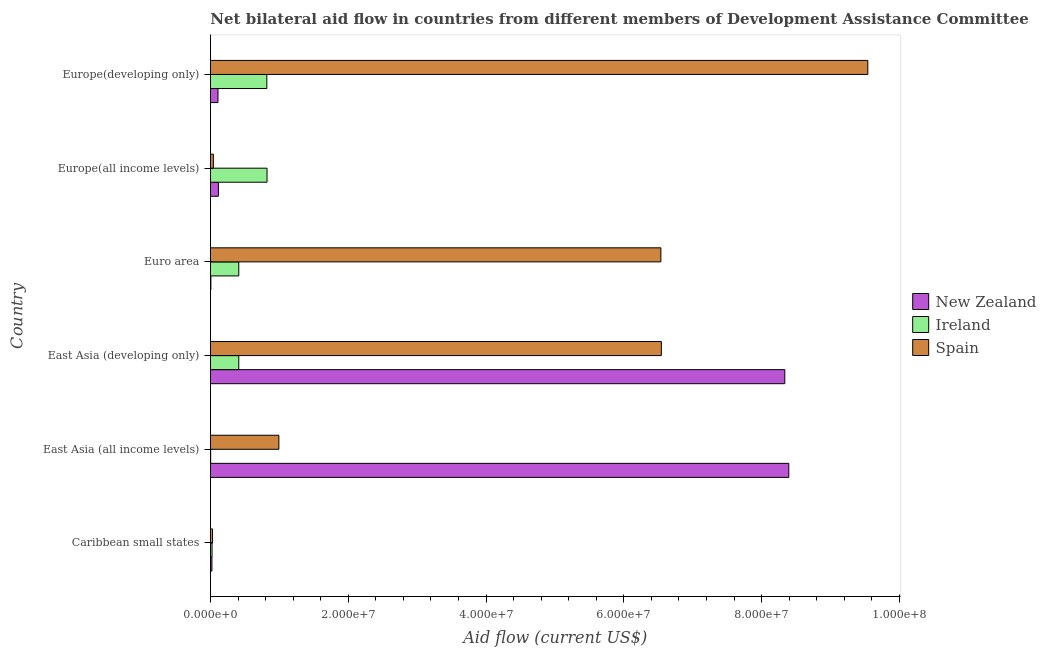How many different coloured bars are there?
Keep it short and to the point. 3. Are the number of bars on each tick of the Y-axis equal?
Your response must be concise. Yes. How many bars are there on the 6th tick from the top?
Ensure brevity in your answer.  3. How many bars are there on the 6th tick from the bottom?
Provide a succinct answer. 3. What is the label of the 1st group of bars from the top?
Provide a short and direct response. Europe(developing only). What is the amount of aid provided by new zealand in Euro area?
Keep it short and to the point. 6.00e+04. Across all countries, what is the maximum amount of aid provided by spain?
Offer a very short reply. 9.54e+07. Across all countries, what is the minimum amount of aid provided by new zealand?
Your answer should be very brief. 6.00e+04. In which country was the amount of aid provided by ireland maximum?
Provide a short and direct response. Europe(all income levels). In which country was the amount of aid provided by ireland minimum?
Keep it short and to the point. East Asia (all income levels). What is the total amount of aid provided by spain in the graph?
Your answer should be compact. 2.37e+08. What is the difference between the amount of aid provided by new zealand in East Asia (developing only) and that in Euro area?
Offer a very short reply. 8.33e+07. What is the difference between the amount of aid provided by new zealand in Caribbean small states and the amount of aid provided by ireland in East Asia (developing only)?
Your response must be concise. -3.90e+06. What is the average amount of aid provided by new zealand per country?
Offer a terse response. 2.83e+07. What is the difference between the amount of aid provided by spain and amount of aid provided by ireland in Europe(developing only)?
Offer a very short reply. 8.72e+07. In how many countries, is the amount of aid provided by new zealand greater than 20000000 US$?
Provide a short and direct response. 2. What is the ratio of the amount of aid provided by new zealand in Europe(all income levels) to that in Europe(developing only)?
Provide a short and direct response. 1.05. Is the difference between the amount of aid provided by spain in Europe(all income levels) and Europe(developing only) greater than the difference between the amount of aid provided by new zealand in Europe(all income levels) and Europe(developing only)?
Your response must be concise. No. What is the difference between the highest and the second highest amount of aid provided by ireland?
Provide a succinct answer. 3.00e+04. What is the difference between the highest and the lowest amount of aid provided by new zealand?
Ensure brevity in your answer.  8.39e+07. Is the sum of the amount of aid provided by new zealand in East Asia (all income levels) and Euro area greater than the maximum amount of aid provided by spain across all countries?
Offer a terse response. No. What does the 3rd bar from the top in East Asia (all income levels) represents?
Your response must be concise. New Zealand. What is the difference between two consecutive major ticks on the X-axis?
Your answer should be very brief. 2.00e+07. Are the values on the major ticks of X-axis written in scientific E-notation?
Offer a very short reply. Yes. Where does the legend appear in the graph?
Keep it short and to the point. Center right. How many legend labels are there?
Offer a terse response. 3. What is the title of the graph?
Your answer should be compact. Net bilateral aid flow in countries from different members of Development Assistance Committee. Does "ICT services" appear as one of the legend labels in the graph?
Your answer should be very brief. No. What is the label or title of the X-axis?
Offer a terse response. Aid flow (current US$). What is the Aid flow (current US$) in New Zealand in Caribbean small states?
Offer a terse response. 2.10e+05. What is the Aid flow (current US$) in Spain in Caribbean small states?
Offer a terse response. 3.00e+05. What is the Aid flow (current US$) of New Zealand in East Asia (all income levels)?
Make the answer very short. 8.40e+07. What is the Aid flow (current US$) in Ireland in East Asia (all income levels)?
Your answer should be compact. 3.00e+04. What is the Aid flow (current US$) in Spain in East Asia (all income levels)?
Keep it short and to the point. 9.93e+06. What is the Aid flow (current US$) in New Zealand in East Asia (developing only)?
Give a very brief answer. 8.34e+07. What is the Aid flow (current US$) of Ireland in East Asia (developing only)?
Provide a short and direct response. 4.11e+06. What is the Aid flow (current US$) of Spain in East Asia (developing only)?
Your answer should be very brief. 6.54e+07. What is the Aid flow (current US$) of Ireland in Euro area?
Make the answer very short. 4.11e+06. What is the Aid flow (current US$) of Spain in Euro area?
Make the answer very short. 6.54e+07. What is the Aid flow (current US$) of New Zealand in Europe(all income levels)?
Offer a very short reply. 1.15e+06. What is the Aid flow (current US$) in Ireland in Europe(all income levels)?
Ensure brevity in your answer.  8.21e+06. What is the Aid flow (current US$) in New Zealand in Europe(developing only)?
Give a very brief answer. 1.09e+06. What is the Aid flow (current US$) in Ireland in Europe(developing only)?
Make the answer very short. 8.18e+06. What is the Aid flow (current US$) in Spain in Europe(developing only)?
Ensure brevity in your answer.  9.54e+07. Across all countries, what is the maximum Aid flow (current US$) in New Zealand?
Keep it short and to the point. 8.40e+07. Across all countries, what is the maximum Aid flow (current US$) in Ireland?
Ensure brevity in your answer.  8.21e+06. Across all countries, what is the maximum Aid flow (current US$) of Spain?
Keep it short and to the point. 9.54e+07. What is the total Aid flow (current US$) in New Zealand in the graph?
Your response must be concise. 1.70e+08. What is the total Aid flow (current US$) in Ireland in the graph?
Make the answer very short. 2.49e+07. What is the total Aid flow (current US$) of Spain in the graph?
Make the answer very short. 2.37e+08. What is the difference between the Aid flow (current US$) in New Zealand in Caribbean small states and that in East Asia (all income levels)?
Your response must be concise. -8.37e+07. What is the difference between the Aid flow (current US$) in Spain in Caribbean small states and that in East Asia (all income levels)?
Your response must be concise. -9.63e+06. What is the difference between the Aid flow (current US$) of New Zealand in Caribbean small states and that in East Asia (developing only)?
Your answer should be very brief. -8.32e+07. What is the difference between the Aid flow (current US$) in Ireland in Caribbean small states and that in East Asia (developing only)?
Offer a very short reply. -3.88e+06. What is the difference between the Aid flow (current US$) of Spain in Caribbean small states and that in East Asia (developing only)?
Give a very brief answer. -6.52e+07. What is the difference between the Aid flow (current US$) of New Zealand in Caribbean small states and that in Euro area?
Ensure brevity in your answer.  1.50e+05. What is the difference between the Aid flow (current US$) of Ireland in Caribbean small states and that in Euro area?
Provide a succinct answer. -3.88e+06. What is the difference between the Aid flow (current US$) of Spain in Caribbean small states and that in Euro area?
Provide a succinct answer. -6.51e+07. What is the difference between the Aid flow (current US$) of New Zealand in Caribbean small states and that in Europe(all income levels)?
Offer a very short reply. -9.40e+05. What is the difference between the Aid flow (current US$) in Ireland in Caribbean small states and that in Europe(all income levels)?
Offer a terse response. -7.98e+06. What is the difference between the Aid flow (current US$) of Spain in Caribbean small states and that in Europe(all income levels)?
Make the answer very short. -1.20e+05. What is the difference between the Aid flow (current US$) of New Zealand in Caribbean small states and that in Europe(developing only)?
Provide a short and direct response. -8.80e+05. What is the difference between the Aid flow (current US$) of Ireland in Caribbean small states and that in Europe(developing only)?
Keep it short and to the point. -7.95e+06. What is the difference between the Aid flow (current US$) of Spain in Caribbean small states and that in Europe(developing only)?
Offer a terse response. -9.51e+07. What is the difference between the Aid flow (current US$) of New Zealand in East Asia (all income levels) and that in East Asia (developing only)?
Your answer should be compact. 5.80e+05. What is the difference between the Aid flow (current US$) of Ireland in East Asia (all income levels) and that in East Asia (developing only)?
Your answer should be compact. -4.08e+06. What is the difference between the Aid flow (current US$) of Spain in East Asia (all income levels) and that in East Asia (developing only)?
Keep it short and to the point. -5.55e+07. What is the difference between the Aid flow (current US$) in New Zealand in East Asia (all income levels) and that in Euro area?
Offer a terse response. 8.39e+07. What is the difference between the Aid flow (current US$) in Ireland in East Asia (all income levels) and that in Euro area?
Ensure brevity in your answer.  -4.08e+06. What is the difference between the Aid flow (current US$) of Spain in East Asia (all income levels) and that in Euro area?
Keep it short and to the point. -5.54e+07. What is the difference between the Aid flow (current US$) in New Zealand in East Asia (all income levels) and that in Europe(all income levels)?
Offer a terse response. 8.28e+07. What is the difference between the Aid flow (current US$) of Ireland in East Asia (all income levels) and that in Europe(all income levels)?
Make the answer very short. -8.18e+06. What is the difference between the Aid flow (current US$) in Spain in East Asia (all income levels) and that in Europe(all income levels)?
Ensure brevity in your answer.  9.51e+06. What is the difference between the Aid flow (current US$) of New Zealand in East Asia (all income levels) and that in Europe(developing only)?
Your answer should be very brief. 8.29e+07. What is the difference between the Aid flow (current US$) of Ireland in East Asia (all income levels) and that in Europe(developing only)?
Offer a terse response. -8.15e+06. What is the difference between the Aid flow (current US$) of Spain in East Asia (all income levels) and that in Europe(developing only)?
Provide a short and direct response. -8.55e+07. What is the difference between the Aid flow (current US$) of New Zealand in East Asia (developing only) and that in Euro area?
Ensure brevity in your answer.  8.33e+07. What is the difference between the Aid flow (current US$) of New Zealand in East Asia (developing only) and that in Europe(all income levels)?
Offer a terse response. 8.22e+07. What is the difference between the Aid flow (current US$) of Ireland in East Asia (developing only) and that in Europe(all income levels)?
Give a very brief answer. -4.10e+06. What is the difference between the Aid flow (current US$) of Spain in East Asia (developing only) and that in Europe(all income levels)?
Ensure brevity in your answer.  6.50e+07. What is the difference between the Aid flow (current US$) of New Zealand in East Asia (developing only) and that in Europe(developing only)?
Offer a very short reply. 8.23e+07. What is the difference between the Aid flow (current US$) in Ireland in East Asia (developing only) and that in Europe(developing only)?
Offer a very short reply. -4.07e+06. What is the difference between the Aid flow (current US$) of Spain in East Asia (developing only) and that in Europe(developing only)?
Keep it short and to the point. -3.00e+07. What is the difference between the Aid flow (current US$) of New Zealand in Euro area and that in Europe(all income levels)?
Give a very brief answer. -1.09e+06. What is the difference between the Aid flow (current US$) of Ireland in Euro area and that in Europe(all income levels)?
Provide a short and direct response. -4.10e+06. What is the difference between the Aid flow (current US$) in Spain in Euro area and that in Europe(all income levels)?
Your answer should be very brief. 6.50e+07. What is the difference between the Aid flow (current US$) in New Zealand in Euro area and that in Europe(developing only)?
Provide a short and direct response. -1.03e+06. What is the difference between the Aid flow (current US$) of Ireland in Euro area and that in Europe(developing only)?
Your answer should be very brief. -4.07e+06. What is the difference between the Aid flow (current US$) of Spain in Euro area and that in Europe(developing only)?
Make the answer very short. -3.00e+07. What is the difference between the Aid flow (current US$) in Ireland in Europe(all income levels) and that in Europe(developing only)?
Offer a very short reply. 3.00e+04. What is the difference between the Aid flow (current US$) of Spain in Europe(all income levels) and that in Europe(developing only)?
Ensure brevity in your answer.  -9.50e+07. What is the difference between the Aid flow (current US$) of New Zealand in Caribbean small states and the Aid flow (current US$) of Ireland in East Asia (all income levels)?
Provide a succinct answer. 1.80e+05. What is the difference between the Aid flow (current US$) of New Zealand in Caribbean small states and the Aid flow (current US$) of Spain in East Asia (all income levels)?
Provide a succinct answer. -9.72e+06. What is the difference between the Aid flow (current US$) in Ireland in Caribbean small states and the Aid flow (current US$) in Spain in East Asia (all income levels)?
Your answer should be very brief. -9.70e+06. What is the difference between the Aid flow (current US$) in New Zealand in Caribbean small states and the Aid flow (current US$) in Ireland in East Asia (developing only)?
Your response must be concise. -3.90e+06. What is the difference between the Aid flow (current US$) in New Zealand in Caribbean small states and the Aid flow (current US$) in Spain in East Asia (developing only)?
Make the answer very short. -6.52e+07. What is the difference between the Aid flow (current US$) of Ireland in Caribbean small states and the Aid flow (current US$) of Spain in East Asia (developing only)?
Provide a succinct answer. -6.52e+07. What is the difference between the Aid flow (current US$) in New Zealand in Caribbean small states and the Aid flow (current US$) in Ireland in Euro area?
Provide a short and direct response. -3.90e+06. What is the difference between the Aid flow (current US$) in New Zealand in Caribbean small states and the Aid flow (current US$) in Spain in Euro area?
Ensure brevity in your answer.  -6.52e+07. What is the difference between the Aid flow (current US$) of Ireland in Caribbean small states and the Aid flow (current US$) of Spain in Euro area?
Make the answer very short. -6.52e+07. What is the difference between the Aid flow (current US$) in New Zealand in Caribbean small states and the Aid flow (current US$) in Ireland in Europe(all income levels)?
Keep it short and to the point. -8.00e+06. What is the difference between the Aid flow (current US$) in New Zealand in Caribbean small states and the Aid flow (current US$) in Spain in Europe(all income levels)?
Make the answer very short. -2.10e+05. What is the difference between the Aid flow (current US$) of Ireland in Caribbean small states and the Aid flow (current US$) of Spain in Europe(all income levels)?
Make the answer very short. -1.90e+05. What is the difference between the Aid flow (current US$) in New Zealand in Caribbean small states and the Aid flow (current US$) in Ireland in Europe(developing only)?
Your answer should be compact. -7.97e+06. What is the difference between the Aid flow (current US$) of New Zealand in Caribbean small states and the Aid flow (current US$) of Spain in Europe(developing only)?
Make the answer very short. -9.52e+07. What is the difference between the Aid flow (current US$) in Ireland in Caribbean small states and the Aid flow (current US$) in Spain in Europe(developing only)?
Provide a succinct answer. -9.52e+07. What is the difference between the Aid flow (current US$) of New Zealand in East Asia (all income levels) and the Aid flow (current US$) of Ireland in East Asia (developing only)?
Offer a very short reply. 7.98e+07. What is the difference between the Aid flow (current US$) of New Zealand in East Asia (all income levels) and the Aid flow (current US$) of Spain in East Asia (developing only)?
Offer a terse response. 1.85e+07. What is the difference between the Aid flow (current US$) of Ireland in East Asia (all income levels) and the Aid flow (current US$) of Spain in East Asia (developing only)?
Your response must be concise. -6.54e+07. What is the difference between the Aid flow (current US$) of New Zealand in East Asia (all income levels) and the Aid flow (current US$) of Ireland in Euro area?
Offer a terse response. 7.98e+07. What is the difference between the Aid flow (current US$) in New Zealand in East Asia (all income levels) and the Aid flow (current US$) in Spain in Euro area?
Your answer should be compact. 1.86e+07. What is the difference between the Aid flow (current US$) in Ireland in East Asia (all income levels) and the Aid flow (current US$) in Spain in Euro area?
Offer a very short reply. -6.54e+07. What is the difference between the Aid flow (current US$) of New Zealand in East Asia (all income levels) and the Aid flow (current US$) of Ireland in Europe(all income levels)?
Provide a succinct answer. 7.57e+07. What is the difference between the Aid flow (current US$) of New Zealand in East Asia (all income levels) and the Aid flow (current US$) of Spain in Europe(all income levels)?
Provide a short and direct response. 8.35e+07. What is the difference between the Aid flow (current US$) in Ireland in East Asia (all income levels) and the Aid flow (current US$) in Spain in Europe(all income levels)?
Keep it short and to the point. -3.90e+05. What is the difference between the Aid flow (current US$) of New Zealand in East Asia (all income levels) and the Aid flow (current US$) of Ireland in Europe(developing only)?
Give a very brief answer. 7.58e+07. What is the difference between the Aid flow (current US$) in New Zealand in East Asia (all income levels) and the Aid flow (current US$) in Spain in Europe(developing only)?
Your answer should be compact. -1.15e+07. What is the difference between the Aid flow (current US$) in Ireland in East Asia (all income levels) and the Aid flow (current US$) in Spain in Europe(developing only)?
Ensure brevity in your answer.  -9.54e+07. What is the difference between the Aid flow (current US$) of New Zealand in East Asia (developing only) and the Aid flow (current US$) of Ireland in Euro area?
Give a very brief answer. 7.93e+07. What is the difference between the Aid flow (current US$) of New Zealand in East Asia (developing only) and the Aid flow (current US$) of Spain in Euro area?
Keep it short and to the point. 1.80e+07. What is the difference between the Aid flow (current US$) of Ireland in East Asia (developing only) and the Aid flow (current US$) of Spain in Euro area?
Provide a succinct answer. -6.13e+07. What is the difference between the Aid flow (current US$) of New Zealand in East Asia (developing only) and the Aid flow (current US$) of Ireland in Europe(all income levels)?
Ensure brevity in your answer.  7.52e+07. What is the difference between the Aid flow (current US$) in New Zealand in East Asia (developing only) and the Aid flow (current US$) in Spain in Europe(all income levels)?
Ensure brevity in your answer.  8.30e+07. What is the difference between the Aid flow (current US$) in Ireland in East Asia (developing only) and the Aid flow (current US$) in Spain in Europe(all income levels)?
Ensure brevity in your answer.  3.69e+06. What is the difference between the Aid flow (current US$) of New Zealand in East Asia (developing only) and the Aid flow (current US$) of Ireland in Europe(developing only)?
Ensure brevity in your answer.  7.52e+07. What is the difference between the Aid flow (current US$) of New Zealand in East Asia (developing only) and the Aid flow (current US$) of Spain in Europe(developing only)?
Your answer should be very brief. -1.20e+07. What is the difference between the Aid flow (current US$) in Ireland in East Asia (developing only) and the Aid flow (current US$) in Spain in Europe(developing only)?
Your answer should be compact. -9.13e+07. What is the difference between the Aid flow (current US$) of New Zealand in Euro area and the Aid flow (current US$) of Ireland in Europe(all income levels)?
Your answer should be very brief. -8.15e+06. What is the difference between the Aid flow (current US$) of New Zealand in Euro area and the Aid flow (current US$) of Spain in Europe(all income levels)?
Keep it short and to the point. -3.60e+05. What is the difference between the Aid flow (current US$) in Ireland in Euro area and the Aid flow (current US$) in Spain in Europe(all income levels)?
Your response must be concise. 3.69e+06. What is the difference between the Aid flow (current US$) in New Zealand in Euro area and the Aid flow (current US$) in Ireland in Europe(developing only)?
Your answer should be very brief. -8.12e+06. What is the difference between the Aid flow (current US$) of New Zealand in Euro area and the Aid flow (current US$) of Spain in Europe(developing only)?
Keep it short and to the point. -9.54e+07. What is the difference between the Aid flow (current US$) in Ireland in Euro area and the Aid flow (current US$) in Spain in Europe(developing only)?
Make the answer very short. -9.13e+07. What is the difference between the Aid flow (current US$) in New Zealand in Europe(all income levels) and the Aid flow (current US$) in Ireland in Europe(developing only)?
Your response must be concise. -7.03e+06. What is the difference between the Aid flow (current US$) in New Zealand in Europe(all income levels) and the Aid flow (current US$) in Spain in Europe(developing only)?
Ensure brevity in your answer.  -9.43e+07. What is the difference between the Aid flow (current US$) in Ireland in Europe(all income levels) and the Aid flow (current US$) in Spain in Europe(developing only)?
Provide a short and direct response. -8.72e+07. What is the average Aid flow (current US$) in New Zealand per country?
Offer a terse response. 2.83e+07. What is the average Aid flow (current US$) in Ireland per country?
Make the answer very short. 4.14e+06. What is the average Aid flow (current US$) in Spain per country?
Make the answer very short. 3.95e+07. What is the difference between the Aid flow (current US$) in Ireland and Aid flow (current US$) in Spain in Caribbean small states?
Keep it short and to the point. -7.00e+04. What is the difference between the Aid flow (current US$) in New Zealand and Aid flow (current US$) in Ireland in East Asia (all income levels)?
Keep it short and to the point. 8.39e+07. What is the difference between the Aid flow (current US$) in New Zealand and Aid flow (current US$) in Spain in East Asia (all income levels)?
Give a very brief answer. 7.40e+07. What is the difference between the Aid flow (current US$) in Ireland and Aid flow (current US$) in Spain in East Asia (all income levels)?
Provide a short and direct response. -9.90e+06. What is the difference between the Aid flow (current US$) in New Zealand and Aid flow (current US$) in Ireland in East Asia (developing only)?
Give a very brief answer. 7.93e+07. What is the difference between the Aid flow (current US$) in New Zealand and Aid flow (current US$) in Spain in East Asia (developing only)?
Provide a short and direct response. 1.79e+07. What is the difference between the Aid flow (current US$) of Ireland and Aid flow (current US$) of Spain in East Asia (developing only)?
Offer a terse response. -6.13e+07. What is the difference between the Aid flow (current US$) in New Zealand and Aid flow (current US$) in Ireland in Euro area?
Make the answer very short. -4.05e+06. What is the difference between the Aid flow (current US$) in New Zealand and Aid flow (current US$) in Spain in Euro area?
Keep it short and to the point. -6.53e+07. What is the difference between the Aid flow (current US$) in Ireland and Aid flow (current US$) in Spain in Euro area?
Your answer should be compact. -6.13e+07. What is the difference between the Aid flow (current US$) of New Zealand and Aid flow (current US$) of Ireland in Europe(all income levels)?
Offer a terse response. -7.06e+06. What is the difference between the Aid flow (current US$) of New Zealand and Aid flow (current US$) of Spain in Europe(all income levels)?
Provide a short and direct response. 7.30e+05. What is the difference between the Aid flow (current US$) in Ireland and Aid flow (current US$) in Spain in Europe(all income levels)?
Your answer should be compact. 7.79e+06. What is the difference between the Aid flow (current US$) in New Zealand and Aid flow (current US$) in Ireland in Europe(developing only)?
Give a very brief answer. -7.09e+06. What is the difference between the Aid flow (current US$) in New Zealand and Aid flow (current US$) in Spain in Europe(developing only)?
Offer a very short reply. -9.43e+07. What is the difference between the Aid flow (current US$) of Ireland and Aid flow (current US$) of Spain in Europe(developing only)?
Your response must be concise. -8.72e+07. What is the ratio of the Aid flow (current US$) in New Zealand in Caribbean small states to that in East Asia (all income levels)?
Offer a very short reply. 0. What is the ratio of the Aid flow (current US$) in Ireland in Caribbean small states to that in East Asia (all income levels)?
Ensure brevity in your answer.  7.67. What is the ratio of the Aid flow (current US$) in Spain in Caribbean small states to that in East Asia (all income levels)?
Your answer should be very brief. 0.03. What is the ratio of the Aid flow (current US$) in New Zealand in Caribbean small states to that in East Asia (developing only)?
Give a very brief answer. 0. What is the ratio of the Aid flow (current US$) of Ireland in Caribbean small states to that in East Asia (developing only)?
Offer a terse response. 0.06. What is the ratio of the Aid flow (current US$) of Spain in Caribbean small states to that in East Asia (developing only)?
Provide a short and direct response. 0. What is the ratio of the Aid flow (current US$) of New Zealand in Caribbean small states to that in Euro area?
Ensure brevity in your answer.  3.5. What is the ratio of the Aid flow (current US$) in Ireland in Caribbean small states to that in Euro area?
Make the answer very short. 0.06. What is the ratio of the Aid flow (current US$) in Spain in Caribbean small states to that in Euro area?
Offer a terse response. 0. What is the ratio of the Aid flow (current US$) of New Zealand in Caribbean small states to that in Europe(all income levels)?
Your answer should be compact. 0.18. What is the ratio of the Aid flow (current US$) of Ireland in Caribbean small states to that in Europe(all income levels)?
Give a very brief answer. 0.03. What is the ratio of the Aid flow (current US$) in New Zealand in Caribbean small states to that in Europe(developing only)?
Make the answer very short. 0.19. What is the ratio of the Aid flow (current US$) of Ireland in Caribbean small states to that in Europe(developing only)?
Offer a very short reply. 0.03. What is the ratio of the Aid flow (current US$) in Spain in Caribbean small states to that in Europe(developing only)?
Give a very brief answer. 0. What is the ratio of the Aid flow (current US$) in New Zealand in East Asia (all income levels) to that in East Asia (developing only)?
Your answer should be compact. 1.01. What is the ratio of the Aid flow (current US$) in Ireland in East Asia (all income levels) to that in East Asia (developing only)?
Keep it short and to the point. 0.01. What is the ratio of the Aid flow (current US$) in Spain in East Asia (all income levels) to that in East Asia (developing only)?
Your response must be concise. 0.15. What is the ratio of the Aid flow (current US$) of New Zealand in East Asia (all income levels) to that in Euro area?
Provide a succinct answer. 1399.17. What is the ratio of the Aid flow (current US$) in Ireland in East Asia (all income levels) to that in Euro area?
Ensure brevity in your answer.  0.01. What is the ratio of the Aid flow (current US$) of Spain in East Asia (all income levels) to that in Euro area?
Provide a succinct answer. 0.15. What is the ratio of the Aid flow (current US$) in Ireland in East Asia (all income levels) to that in Europe(all income levels)?
Provide a succinct answer. 0. What is the ratio of the Aid flow (current US$) in Spain in East Asia (all income levels) to that in Europe(all income levels)?
Give a very brief answer. 23.64. What is the ratio of the Aid flow (current US$) in New Zealand in East Asia (all income levels) to that in Europe(developing only)?
Your response must be concise. 77.02. What is the ratio of the Aid flow (current US$) of Ireland in East Asia (all income levels) to that in Europe(developing only)?
Your answer should be compact. 0. What is the ratio of the Aid flow (current US$) in Spain in East Asia (all income levels) to that in Europe(developing only)?
Make the answer very short. 0.1. What is the ratio of the Aid flow (current US$) in New Zealand in East Asia (developing only) to that in Euro area?
Ensure brevity in your answer.  1389.5. What is the ratio of the Aid flow (current US$) of Spain in East Asia (developing only) to that in Euro area?
Provide a succinct answer. 1. What is the ratio of the Aid flow (current US$) of New Zealand in East Asia (developing only) to that in Europe(all income levels)?
Ensure brevity in your answer.  72.5. What is the ratio of the Aid flow (current US$) of Ireland in East Asia (developing only) to that in Europe(all income levels)?
Offer a terse response. 0.5. What is the ratio of the Aid flow (current US$) of Spain in East Asia (developing only) to that in Europe(all income levels)?
Your answer should be very brief. 155.83. What is the ratio of the Aid flow (current US$) in New Zealand in East Asia (developing only) to that in Europe(developing only)?
Your answer should be compact. 76.49. What is the ratio of the Aid flow (current US$) of Ireland in East Asia (developing only) to that in Europe(developing only)?
Give a very brief answer. 0.5. What is the ratio of the Aid flow (current US$) of Spain in East Asia (developing only) to that in Europe(developing only)?
Make the answer very short. 0.69. What is the ratio of the Aid flow (current US$) of New Zealand in Euro area to that in Europe(all income levels)?
Ensure brevity in your answer.  0.05. What is the ratio of the Aid flow (current US$) in Ireland in Euro area to that in Europe(all income levels)?
Ensure brevity in your answer.  0.5. What is the ratio of the Aid flow (current US$) of Spain in Euro area to that in Europe(all income levels)?
Provide a short and direct response. 155.67. What is the ratio of the Aid flow (current US$) of New Zealand in Euro area to that in Europe(developing only)?
Make the answer very short. 0.06. What is the ratio of the Aid flow (current US$) of Ireland in Euro area to that in Europe(developing only)?
Give a very brief answer. 0.5. What is the ratio of the Aid flow (current US$) in Spain in Euro area to that in Europe(developing only)?
Your response must be concise. 0.69. What is the ratio of the Aid flow (current US$) of New Zealand in Europe(all income levels) to that in Europe(developing only)?
Offer a very short reply. 1.05. What is the ratio of the Aid flow (current US$) in Ireland in Europe(all income levels) to that in Europe(developing only)?
Make the answer very short. 1. What is the ratio of the Aid flow (current US$) in Spain in Europe(all income levels) to that in Europe(developing only)?
Offer a terse response. 0. What is the difference between the highest and the second highest Aid flow (current US$) of New Zealand?
Offer a very short reply. 5.80e+05. What is the difference between the highest and the second highest Aid flow (current US$) in Spain?
Provide a succinct answer. 3.00e+07. What is the difference between the highest and the lowest Aid flow (current US$) in New Zealand?
Your response must be concise. 8.39e+07. What is the difference between the highest and the lowest Aid flow (current US$) of Ireland?
Your answer should be very brief. 8.18e+06. What is the difference between the highest and the lowest Aid flow (current US$) of Spain?
Offer a very short reply. 9.51e+07. 